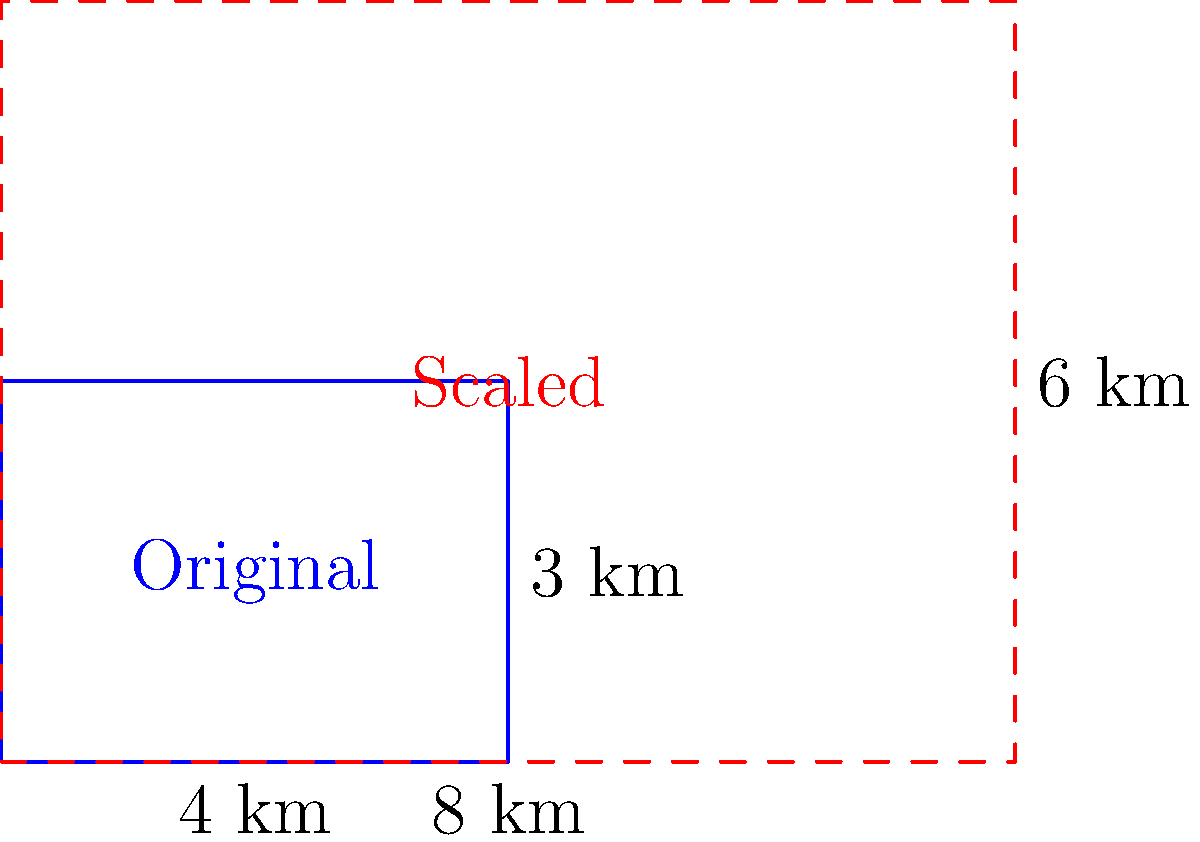In an ecological study of a protected habitat, you need to scale up a diagram of the current range to represent a proposed expansion. The original habitat is rectangular, measuring 4 km by 3 km. If the new habitat area needs to be 4 times larger, what should be the dimensions of the scaled-up diagram to maintain the same aspect ratio? To solve this problem, we need to follow these steps:

1) First, let's calculate the area of the original habitat:
   Area = length × width
   $A_1 = 4 \text{ km} \times 3 \text{ km} = 12 \text{ km}^2$

2) The new habitat area needs to be 4 times larger, so:
   $A_2 = 4 \times A_1 = 4 \times 12 \text{ km}^2 = 48 \text{ km}^2$

3) To maintain the same aspect ratio, we need to scale both dimensions by the same factor. Let's call this factor $k$.

4) If we scale both dimensions by $k$, the new area will be $k^2$ times the original area:
   $k^2 \times A_1 = A_2$
   $k^2 \times 12 = 48$
   $k^2 = 4$
   $k = \sqrt{4} = 2$

5) Now we can calculate the new dimensions:
   New length = $4 \text{ km} \times 2 = 8 \text{ km}$
   New width = $3 \text{ km} \times 2 = 6 \text{ km}$

Therefore, the scaled-up diagram should measure 8 km by 6 km.
Answer: 8 km × 6 km 